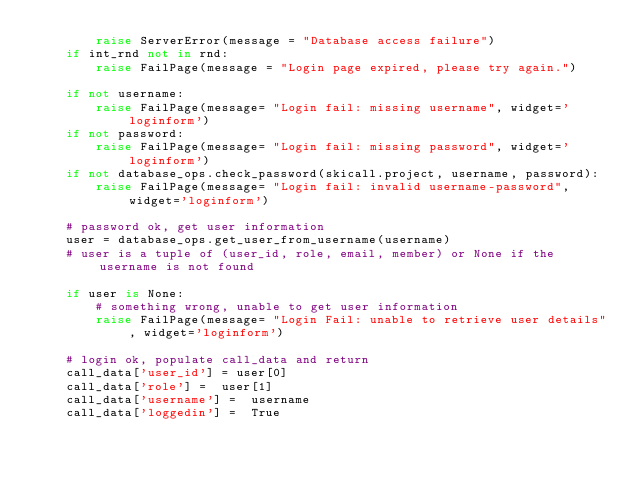<code> <loc_0><loc_0><loc_500><loc_500><_Python_>        raise ServerError(message = "Database access failure")
    if int_rnd not in rnd:
        raise FailPage(message = "Login page expired, please try again.")
    
    if not username:
        raise FailPage(message= "Login fail: missing username", widget='loginform')
    if not password:
        raise FailPage(message= "Login fail: missing password", widget='loginform')
    if not database_ops.check_password(skicall.project, username, password):
        raise FailPage(message= "Login fail: invalid username-password", widget='loginform')

    # password ok, get user information
    user = database_ops.get_user_from_username(username)
    # user is a tuple of (user_id, role, email, member) or None if the username is not found

    if user is None:
        # something wrong, unable to get user information
        raise FailPage(message= "Login Fail: unable to retrieve user details", widget='loginform')

    # login ok, populate call_data and return
    call_data['user_id'] = user[0]
    call_data['role'] =  user[1]
    call_data['username'] =  username
    call_data['loggedin'] =  True
</code> 